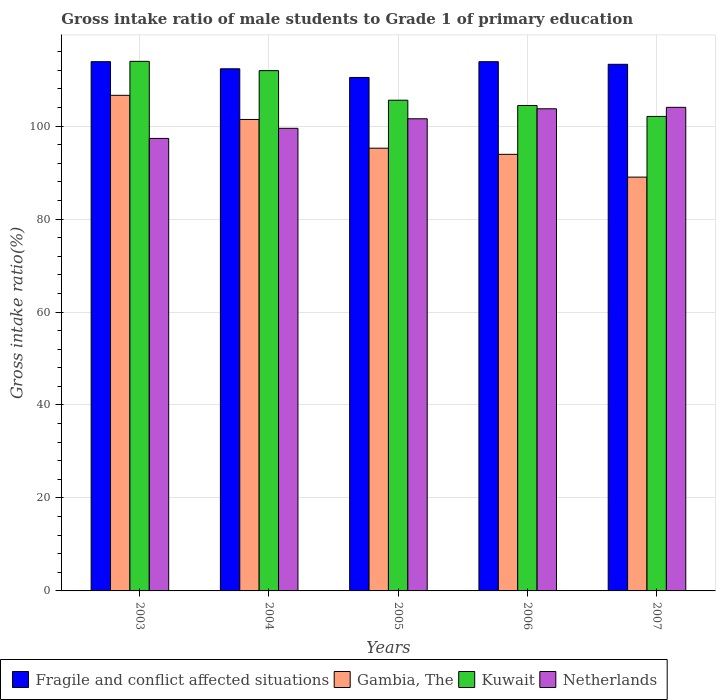How many groups of bars are there?
Ensure brevity in your answer.  5. Are the number of bars per tick equal to the number of legend labels?
Give a very brief answer. Yes. How many bars are there on the 2nd tick from the left?
Your answer should be compact. 4. In how many cases, is the number of bars for a given year not equal to the number of legend labels?
Offer a terse response. 0. What is the gross intake ratio in Netherlands in 2006?
Your answer should be very brief. 103.73. Across all years, what is the maximum gross intake ratio in Kuwait?
Offer a very short reply. 113.93. Across all years, what is the minimum gross intake ratio in Fragile and conflict affected situations?
Ensure brevity in your answer.  110.47. In which year was the gross intake ratio in Kuwait minimum?
Keep it short and to the point. 2007. What is the total gross intake ratio in Kuwait in the graph?
Offer a very short reply. 537.97. What is the difference between the gross intake ratio in Fragile and conflict affected situations in 2005 and that in 2007?
Provide a short and direct response. -2.83. What is the difference between the gross intake ratio in Kuwait in 2007 and the gross intake ratio in Netherlands in 2003?
Give a very brief answer. 4.73. What is the average gross intake ratio in Kuwait per year?
Make the answer very short. 107.59. In the year 2004, what is the difference between the gross intake ratio in Netherlands and gross intake ratio in Gambia, The?
Offer a very short reply. -1.9. In how many years, is the gross intake ratio in Fragile and conflict affected situations greater than 8 %?
Your response must be concise. 5. What is the ratio of the gross intake ratio in Gambia, The in 2003 to that in 2007?
Provide a succinct answer. 1.2. Is the gross intake ratio in Gambia, The in 2005 less than that in 2007?
Give a very brief answer. No. Is the difference between the gross intake ratio in Netherlands in 2003 and 2004 greater than the difference between the gross intake ratio in Gambia, The in 2003 and 2004?
Provide a short and direct response. No. What is the difference between the highest and the second highest gross intake ratio in Kuwait?
Your answer should be compact. 2. What is the difference between the highest and the lowest gross intake ratio in Gambia, The?
Offer a very short reply. 17.6. In how many years, is the gross intake ratio in Fragile and conflict affected situations greater than the average gross intake ratio in Fragile and conflict affected situations taken over all years?
Offer a terse response. 3. Is the sum of the gross intake ratio in Kuwait in 2006 and 2007 greater than the maximum gross intake ratio in Gambia, The across all years?
Your response must be concise. Yes. What does the 2nd bar from the left in 2003 represents?
Offer a terse response. Gambia, The. What does the 2nd bar from the right in 2007 represents?
Give a very brief answer. Kuwait. How many bars are there?
Give a very brief answer. 20. How many years are there in the graph?
Your response must be concise. 5. What is the difference between two consecutive major ticks on the Y-axis?
Your answer should be compact. 20. Does the graph contain any zero values?
Offer a very short reply. No. What is the title of the graph?
Ensure brevity in your answer.  Gross intake ratio of male students to Grade 1 of primary education. Does "Dominica" appear as one of the legend labels in the graph?
Provide a short and direct response. No. What is the label or title of the Y-axis?
Offer a very short reply. Gross intake ratio(%). What is the Gross intake ratio(%) of Fragile and conflict affected situations in 2003?
Your answer should be compact. 113.86. What is the Gross intake ratio(%) in Gambia, The in 2003?
Ensure brevity in your answer.  106.63. What is the Gross intake ratio(%) of Kuwait in 2003?
Your answer should be compact. 113.93. What is the Gross intake ratio(%) of Netherlands in 2003?
Offer a terse response. 97.35. What is the Gross intake ratio(%) of Fragile and conflict affected situations in 2004?
Keep it short and to the point. 112.33. What is the Gross intake ratio(%) of Gambia, The in 2004?
Offer a terse response. 101.43. What is the Gross intake ratio(%) in Kuwait in 2004?
Provide a short and direct response. 111.94. What is the Gross intake ratio(%) of Netherlands in 2004?
Your answer should be very brief. 99.53. What is the Gross intake ratio(%) in Fragile and conflict affected situations in 2005?
Your answer should be very brief. 110.47. What is the Gross intake ratio(%) of Gambia, The in 2005?
Keep it short and to the point. 95.25. What is the Gross intake ratio(%) in Kuwait in 2005?
Your answer should be compact. 105.57. What is the Gross intake ratio(%) in Netherlands in 2005?
Provide a short and direct response. 101.58. What is the Gross intake ratio(%) of Fragile and conflict affected situations in 2006?
Give a very brief answer. 113.86. What is the Gross intake ratio(%) of Gambia, The in 2006?
Provide a succinct answer. 93.93. What is the Gross intake ratio(%) in Kuwait in 2006?
Your answer should be compact. 104.44. What is the Gross intake ratio(%) of Netherlands in 2006?
Keep it short and to the point. 103.73. What is the Gross intake ratio(%) in Fragile and conflict affected situations in 2007?
Make the answer very short. 113.3. What is the Gross intake ratio(%) of Gambia, The in 2007?
Ensure brevity in your answer.  89.03. What is the Gross intake ratio(%) of Kuwait in 2007?
Offer a terse response. 102.08. What is the Gross intake ratio(%) in Netherlands in 2007?
Offer a very short reply. 104.04. Across all years, what is the maximum Gross intake ratio(%) in Fragile and conflict affected situations?
Offer a terse response. 113.86. Across all years, what is the maximum Gross intake ratio(%) of Gambia, The?
Provide a short and direct response. 106.63. Across all years, what is the maximum Gross intake ratio(%) in Kuwait?
Your answer should be compact. 113.93. Across all years, what is the maximum Gross intake ratio(%) in Netherlands?
Ensure brevity in your answer.  104.04. Across all years, what is the minimum Gross intake ratio(%) of Fragile and conflict affected situations?
Ensure brevity in your answer.  110.47. Across all years, what is the minimum Gross intake ratio(%) of Gambia, The?
Offer a very short reply. 89.03. Across all years, what is the minimum Gross intake ratio(%) in Kuwait?
Provide a succinct answer. 102.08. Across all years, what is the minimum Gross intake ratio(%) in Netherlands?
Keep it short and to the point. 97.35. What is the total Gross intake ratio(%) of Fragile and conflict affected situations in the graph?
Ensure brevity in your answer.  563.82. What is the total Gross intake ratio(%) in Gambia, The in the graph?
Provide a succinct answer. 486.26. What is the total Gross intake ratio(%) of Kuwait in the graph?
Provide a succinct answer. 537.97. What is the total Gross intake ratio(%) in Netherlands in the graph?
Your response must be concise. 506.23. What is the difference between the Gross intake ratio(%) in Fragile and conflict affected situations in 2003 and that in 2004?
Provide a short and direct response. 1.53. What is the difference between the Gross intake ratio(%) in Gambia, The in 2003 and that in 2004?
Provide a succinct answer. 5.19. What is the difference between the Gross intake ratio(%) of Kuwait in 2003 and that in 2004?
Ensure brevity in your answer.  2. What is the difference between the Gross intake ratio(%) of Netherlands in 2003 and that in 2004?
Your answer should be very brief. -2.18. What is the difference between the Gross intake ratio(%) in Fragile and conflict affected situations in 2003 and that in 2005?
Provide a succinct answer. 3.39. What is the difference between the Gross intake ratio(%) in Gambia, The in 2003 and that in 2005?
Your answer should be compact. 11.38. What is the difference between the Gross intake ratio(%) of Kuwait in 2003 and that in 2005?
Your response must be concise. 8.36. What is the difference between the Gross intake ratio(%) in Netherlands in 2003 and that in 2005?
Make the answer very short. -4.23. What is the difference between the Gross intake ratio(%) in Fragile and conflict affected situations in 2003 and that in 2006?
Provide a short and direct response. 0. What is the difference between the Gross intake ratio(%) of Gambia, The in 2003 and that in 2006?
Ensure brevity in your answer.  12.7. What is the difference between the Gross intake ratio(%) in Kuwait in 2003 and that in 2006?
Keep it short and to the point. 9.49. What is the difference between the Gross intake ratio(%) of Netherlands in 2003 and that in 2006?
Offer a terse response. -6.38. What is the difference between the Gross intake ratio(%) of Fragile and conflict affected situations in 2003 and that in 2007?
Offer a terse response. 0.56. What is the difference between the Gross intake ratio(%) of Gambia, The in 2003 and that in 2007?
Your response must be concise. 17.6. What is the difference between the Gross intake ratio(%) of Kuwait in 2003 and that in 2007?
Your response must be concise. 11.85. What is the difference between the Gross intake ratio(%) of Netherlands in 2003 and that in 2007?
Offer a very short reply. -6.69. What is the difference between the Gross intake ratio(%) in Fragile and conflict affected situations in 2004 and that in 2005?
Your response must be concise. 1.86. What is the difference between the Gross intake ratio(%) in Gambia, The in 2004 and that in 2005?
Provide a succinct answer. 6.18. What is the difference between the Gross intake ratio(%) in Kuwait in 2004 and that in 2005?
Offer a terse response. 6.36. What is the difference between the Gross intake ratio(%) in Netherlands in 2004 and that in 2005?
Keep it short and to the point. -2.05. What is the difference between the Gross intake ratio(%) in Fragile and conflict affected situations in 2004 and that in 2006?
Provide a succinct answer. -1.53. What is the difference between the Gross intake ratio(%) of Gambia, The in 2004 and that in 2006?
Keep it short and to the point. 7.5. What is the difference between the Gross intake ratio(%) of Kuwait in 2004 and that in 2006?
Your response must be concise. 7.49. What is the difference between the Gross intake ratio(%) of Netherlands in 2004 and that in 2006?
Ensure brevity in your answer.  -4.2. What is the difference between the Gross intake ratio(%) of Fragile and conflict affected situations in 2004 and that in 2007?
Offer a very short reply. -0.97. What is the difference between the Gross intake ratio(%) in Gambia, The in 2004 and that in 2007?
Make the answer very short. 12.4. What is the difference between the Gross intake ratio(%) in Kuwait in 2004 and that in 2007?
Your answer should be compact. 9.85. What is the difference between the Gross intake ratio(%) in Netherlands in 2004 and that in 2007?
Offer a very short reply. -4.51. What is the difference between the Gross intake ratio(%) of Fragile and conflict affected situations in 2005 and that in 2006?
Offer a very short reply. -3.39. What is the difference between the Gross intake ratio(%) of Gambia, The in 2005 and that in 2006?
Provide a short and direct response. 1.32. What is the difference between the Gross intake ratio(%) of Kuwait in 2005 and that in 2006?
Give a very brief answer. 1.13. What is the difference between the Gross intake ratio(%) of Netherlands in 2005 and that in 2006?
Provide a succinct answer. -2.15. What is the difference between the Gross intake ratio(%) of Fragile and conflict affected situations in 2005 and that in 2007?
Offer a terse response. -2.83. What is the difference between the Gross intake ratio(%) in Gambia, The in 2005 and that in 2007?
Your answer should be compact. 6.22. What is the difference between the Gross intake ratio(%) in Kuwait in 2005 and that in 2007?
Offer a very short reply. 3.49. What is the difference between the Gross intake ratio(%) in Netherlands in 2005 and that in 2007?
Make the answer very short. -2.46. What is the difference between the Gross intake ratio(%) in Fragile and conflict affected situations in 2006 and that in 2007?
Provide a short and direct response. 0.56. What is the difference between the Gross intake ratio(%) in Gambia, The in 2006 and that in 2007?
Offer a very short reply. 4.9. What is the difference between the Gross intake ratio(%) of Kuwait in 2006 and that in 2007?
Your answer should be very brief. 2.36. What is the difference between the Gross intake ratio(%) in Netherlands in 2006 and that in 2007?
Your answer should be very brief. -0.31. What is the difference between the Gross intake ratio(%) in Fragile and conflict affected situations in 2003 and the Gross intake ratio(%) in Gambia, The in 2004?
Your answer should be compact. 12.43. What is the difference between the Gross intake ratio(%) of Fragile and conflict affected situations in 2003 and the Gross intake ratio(%) of Kuwait in 2004?
Your response must be concise. 1.93. What is the difference between the Gross intake ratio(%) of Fragile and conflict affected situations in 2003 and the Gross intake ratio(%) of Netherlands in 2004?
Give a very brief answer. 14.34. What is the difference between the Gross intake ratio(%) of Gambia, The in 2003 and the Gross intake ratio(%) of Kuwait in 2004?
Make the answer very short. -5.31. What is the difference between the Gross intake ratio(%) in Gambia, The in 2003 and the Gross intake ratio(%) in Netherlands in 2004?
Your response must be concise. 7.1. What is the difference between the Gross intake ratio(%) in Kuwait in 2003 and the Gross intake ratio(%) in Netherlands in 2004?
Ensure brevity in your answer.  14.41. What is the difference between the Gross intake ratio(%) of Fragile and conflict affected situations in 2003 and the Gross intake ratio(%) of Gambia, The in 2005?
Offer a very short reply. 18.61. What is the difference between the Gross intake ratio(%) of Fragile and conflict affected situations in 2003 and the Gross intake ratio(%) of Kuwait in 2005?
Offer a terse response. 8.29. What is the difference between the Gross intake ratio(%) of Fragile and conflict affected situations in 2003 and the Gross intake ratio(%) of Netherlands in 2005?
Your answer should be compact. 12.28. What is the difference between the Gross intake ratio(%) of Gambia, The in 2003 and the Gross intake ratio(%) of Kuwait in 2005?
Give a very brief answer. 1.05. What is the difference between the Gross intake ratio(%) of Gambia, The in 2003 and the Gross intake ratio(%) of Netherlands in 2005?
Your answer should be compact. 5.04. What is the difference between the Gross intake ratio(%) of Kuwait in 2003 and the Gross intake ratio(%) of Netherlands in 2005?
Provide a short and direct response. 12.35. What is the difference between the Gross intake ratio(%) of Fragile and conflict affected situations in 2003 and the Gross intake ratio(%) of Gambia, The in 2006?
Your response must be concise. 19.93. What is the difference between the Gross intake ratio(%) in Fragile and conflict affected situations in 2003 and the Gross intake ratio(%) in Kuwait in 2006?
Give a very brief answer. 9.42. What is the difference between the Gross intake ratio(%) in Fragile and conflict affected situations in 2003 and the Gross intake ratio(%) in Netherlands in 2006?
Offer a terse response. 10.13. What is the difference between the Gross intake ratio(%) of Gambia, The in 2003 and the Gross intake ratio(%) of Kuwait in 2006?
Your answer should be very brief. 2.18. What is the difference between the Gross intake ratio(%) of Gambia, The in 2003 and the Gross intake ratio(%) of Netherlands in 2006?
Ensure brevity in your answer.  2.89. What is the difference between the Gross intake ratio(%) of Kuwait in 2003 and the Gross intake ratio(%) of Netherlands in 2006?
Provide a succinct answer. 10.2. What is the difference between the Gross intake ratio(%) of Fragile and conflict affected situations in 2003 and the Gross intake ratio(%) of Gambia, The in 2007?
Provide a succinct answer. 24.83. What is the difference between the Gross intake ratio(%) in Fragile and conflict affected situations in 2003 and the Gross intake ratio(%) in Kuwait in 2007?
Your answer should be compact. 11.78. What is the difference between the Gross intake ratio(%) in Fragile and conflict affected situations in 2003 and the Gross intake ratio(%) in Netherlands in 2007?
Offer a very short reply. 9.82. What is the difference between the Gross intake ratio(%) in Gambia, The in 2003 and the Gross intake ratio(%) in Kuwait in 2007?
Keep it short and to the point. 4.54. What is the difference between the Gross intake ratio(%) of Gambia, The in 2003 and the Gross intake ratio(%) of Netherlands in 2007?
Make the answer very short. 2.58. What is the difference between the Gross intake ratio(%) of Kuwait in 2003 and the Gross intake ratio(%) of Netherlands in 2007?
Provide a short and direct response. 9.89. What is the difference between the Gross intake ratio(%) of Fragile and conflict affected situations in 2004 and the Gross intake ratio(%) of Gambia, The in 2005?
Your answer should be very brief. 17.08. What is the difference between the Gross intake ratio(%) of Fragile and conflict affected situations in 2004 and the Gross intake ratio(%) of Kuwait in 2005?
Provide a short and direct response. 6.76. What is the difference between the Gross intake ratio(%) in Fragile and conflict affected situations in 2004 and the Gross intake ratio(%) in Netherlands in 2005?
Offer a very short reply. 10.75. What is the difference between the Gross intake ratio(%) of Gambia, The in 2004 and the Gross intake ratio(%) of Kuwait in 2005?
Your response must be concise. -4.14. What is the difference between the Gross intake ratio(%) of Gambia, The in 2004 and the Gross intake ratio(%) of Netherlands in 2005?
Offer a terse response. -0.15. What is the difference between the Gross intake ratio(%) in Kuwait in 2004 and the Gross intake ratio(%) in Netherlands in 2005?
Provide a short and direct response. 10.36. What is the difference between the Gross intake ratio(%) of Fragile and conflict affected situations in 2004 and the Gross intake ratio(%) of Gambia, The in 2006?
Your response must be concise. 18.4. What is the difference between the Gross intake ratio(%) of Fragile and conflict affected situations in 2004 and the Gross intake ratio(%) of Kuwait in 2006?
Ensure brevity in your answer.  7.89. What is the difference between the Gross intake ratio(%) of Fragile and conflict affected situations in 2004 and the Gross intake ratio(%) of Netherlands in 2006?
Your response must be concise. 8.6. What is the difference between the Gross intake ratio(%) in Gambia, The in 2004 and the Gross intake ratio(%) in Kuwait in 2006?
Your response must be concise. -3.01. What is the difference between the Gross intake ratio(%) of Gambia, The in 2004 and the Gross intake ratio(%) of Netherlands in 2006?
Your answer should be compact. -2.3. What is the difference between the Gross intake ratio(%) of Kuwait in 2004 and the Gross intake ratio(%) of Netherlands in 2006?
Your answer should be compact. 8.21. What is the difference between the Gross intake ratio(%) of Fragile and conflict affected situations in 2004 and the Gross intake ratio(%) of Gambia, The in 2007?
Provide a succinct answer. 23.3. What is the difference between the Gross intake ratio(%) in Fragile and conflict affected situations in 2004 and the Gross intake ratio(%) in Kuwait in 2007?
Provide a succinct answer. 10.25. What is the difference between the Gross intake ratio(%) in Fragile and conflict affected situations in 2004 and the Gross intake ratio(%) in Netherlands in 2007?
Offer a very short reply. 8.29. What is the difference between the Gross intake ratio(%) of Gambia, The in 2004 and the Gross intake ratio(%) of Kuwait in 2007?
Your response must be concise. -0.65. What is the difference between the Gross intake ratio(%) of Gambia, The in 2004 and the Gross intake ratio(%) of Netherlands in 2007?
Keep it short and to the point. -2.61. What is the difference between the Gross intake ratio(%) in Kuwait in 2004 and the Gross intake ratio(%) in Netherlands in 2007?
Your answer should be very brief. 7.9. What is the difference between the Gross intake ratio(%) in Fragile and conflict affected situations in 2005 and the Gross intake ratio(%) in Gambia, The in 2006?
Offer a very short reply. 16.54. What is the difference between the Gross intake ratio(%) in Fragile and conflict affected situations in 2005 and the Gross intake ratio(%) in Kuwait in 2006?
Provide a short and direct response. 6.03. What is the difference between the Gross intake ratio(%) of Fragile and conflict affected situations in 2005 and the Gross intake ratio(%) of Netherlands in 2006?
Keep it short and to the point. 6.74. What is the difference between the Gross intake ratio(%) in Gambia, The in 2005 and the Gross intake ratio(%) in Kuwait in 2006?
Offer a terse response. -9.19. What is the difference between the Gross intake ratio(%) in Gambia, The in 2005 and the Gross intake ratio(%) in Netherlands in 2006?
Ensure brevity in your answer.  -8.48. What is the difference between the Gross intake ratio(%) of Kuwait in 2005 and the Gross intake ratio(%) of Netherlands in 2006?
Provide a short and direct response. 1.84. What is the difference between the Gross intake ratio(%) in Fragile and conflict affected situations in 2005 and the Gross intake ratio(%) in Gambia, The in 2007?
Make the answer very short. 21.44. What is the difference between the Gross intake ratio(%) in Fragile and conflict affected situations in 2005 and the Gross intake ratio(%) in Kuwait in 2007?
Keep it short and to the point. 8.38. What is the difference between the Gross intake ratio(%) in Fragile and conflict affected situations in 2005 and the Gross intake ratio(%) in Netherlands in 2007?
Offer a terse response. 6.43. What is the difference between the Gross intake ratio(%) of Gambia, The in 2005 and the Gross intake ratio(%) of Kuwait in 2007?
Ensure brevity in your answer.  -6.84. What is the difference between the Gross intake ratio(%) in Gambia, The in 2005 and the Gross intake ratio(%) in Netherlands in 2007?
Ensure brevity in your answer.  -8.79. What is the difference between the Gross intake ratio(%) of Kuwait in 2005 and the Gross intake ratio(%) of Netherlands in 2007?
Offer a terse response. 1.53. What is the difference between the Gross intake ratio(%) of Fragile and conflict affected situations in 2006 and the Gross intake ratio(%) of Gambia, The in 2007?
Offer a very short reply. 24.83. What is the difference between the Gross intake ratio(%) in Fragile and conflict affected situations in 2006 and the Gross intake ratio(%) in Kuwait in 2007?
Your answer should be very brief. 11.78. What is the difference between the Gross intake ratio(%) in Fragile and conflict affected situations in 2006 and the Gross intake ratio(%) in Netherlands in 2007?
Provide a succinct answer. 9.82. What is the difference between the Gross intake ratio(%) in Gambia, The in 2006 and the Gross intake ratio(%) in Kuwait in 2007?
Your response must be concise. -8.16. What is the difference between the Gross intake ratio(%) of Gambia, The in 2006 and the Gross intake ratio(%) of Netherlands in 2007?
Offer a very short reply. -10.11. What is the difference between the Gross intake ratio(%) in Kuwait in 2006 and the Gross intake ratio(%) in Netherlands in 2007?
Make the answer very short. 0.4. What is the average Gross intake ratio(%) in Fragile and conflict affected situations per year?
Give a very brief answer. 112.76. What is the average Gross intake ratio(%) of Gambia, The per year?
Provide a short and direct response. 97.25. What is the average Gross intake ratio(%) of Kuwait per year?
Offer a very short reply. 107.59. What is the average Gross intake ratio(%) of Netherlands per year?
Provide a short and direct response. 101.25. In the year 2003, what is the difference between the Gross intake ratio(%) of Fragile and conflict affected situations and Gross intake ratio(%) of Gambia, The?
Provide a short and direct response. 7.24. In the year 2003, what is the difference between the Gross intake ratio(%) in Fragile and conflict affected situations and Gross intake ratio(%) in Kuwait?
Your response must be concise. -0.07. In the year 2003, what is the difference between the Gross intake ratio(%) of Fragile and conflict affected situations and Gross intake ratio(%) of Netherlands?
Keep it short and to the point. 16.51. In the year 2003, what is the difference between the Gross intake ratio(%) in Gambia, The and Gross intake ratio(%) in Kuwait?
Provide a succinct answer. -7.31. In the year 2003, what is the difference between the Gross intake ratio(%) of Gambia, The and Gross intake ratio(%) of Netherlands?
Give a very brief answer. 9.28. In the year 2003, what is the difference between the Gross intake ratio(%) in Kuwait and Gross intake ratio(%) in Netherlands?
Your response must be concise. 16.58. In the year 2004, what is the difference between the Gross intake ratio(%) in Fragile and conflict affected situations and Gross intake ratio(%) in Gambia, The?
Your response must be concise. 10.9. In the year 2004, what is the difference between the Gross intake ratio(%) of Fragile and conflict affected situations and Gross intake ratio(%) of Kuwait?
Provide a succinct answer. 0.4. In the year 2004, what is the difference between the Gross intake ratio(%) of Fragile and conflict affected situations and Gross intake ratio(%) of Netherlands?
Your answer should be very brief. 12.81. In the year 2004, what is the difference between the Gross intake ratio(%) of Gambia, The and Gross intake ratio(%) of Kuwait?
Keep it short and to the point. -10.51. In the year 2004, what is the difference between the Gross intake ratio(%) of Gambia, The and Gross intake ratio(%) of Netherlands?
Provide a short and direct response. 1.9. In the year 2004, what is the difference between the Gross intake ratio(%) of Kuwait and Gross intake ratio(%) of Netherlands?
Provide a short and direct response. 12.41. In the year 2005, what is the difference between the Gross intake ratio(%) of Fragile and conflict affected situations and Gross intake ratio(%) of Gambia, The?
Give a very brief answer. 15.22. In the year 2005, what is the difference between the Gross intake ratio(%) in Fragile and conflict affected situations and Gross intake ratio(%) in Kuwait?
Offer a very short reply. 4.89. In the year 2005, what is the difference between the Gross intake ratio(%) of Fragile and conflict affected situations and Gross intake ratio(%) of Netherlands?
Provide a succinct answer. 8.89. In the year 2005, what is the difference between the Gross intake ratio(%) in Gambia, The and Gross intake ratio(%) in Kuwait?
Your answer should be very brief. -10.32. In the year 2005, what is the difference between the Gross intake ratio(%) in Gambia, The and Gross intake ratio(%) in Netherlands?
Provide a short and direct response. -6.33. In the year 2005, what is the difference between the Gross intake ratio(%) in Kuwait and Gross intake ratio(%) in Netherlands?
Give a very brief answer. 3.99. In the year 2006, what is the difference between the Gross intake ratio(%) of Fragile and conflict affected situations and Gross intake ratio(%) of Gambia, The?
Your answer should be compact. 19.93. In the year 2006, what is the difference between the Gross intake ratio(%) of Fragile and conflict affected situations and Gross intake ratio(%) of Kuwait?
Your answer should be very brief. 9.42. In the year 2006, what is the difference between the Gross intake ratio(%) of Fragile and conflict affected situations and Gross intake ratio(%) of Netherlands?
Your answer should be very brief. 10.13. In the year 2006, what is the difference between the Gross intake ratio(%) of Gambia, The and Gross intake ratio(%) of Kuwait?
Give a very brief answer. -10.51. In the year 2006, what is the difference between the Gross intake ratio(%) in Gambia, The and Gross intake ratio(%) in Netherlands?
Keep it short and to the point. -9.8. In the year 2006, what is the difference between the Gross intake ratio(%) in Kuwait and Gross intake ratio(%) in Netherlands?
Give a very brief answer. 0.71. In the year 2007, what is the difference between the Gross intake ratio(%) in Fragile and conflict affected situations and Gross intake ratio(%) in Gambia, The?
Offer a very short reply. 24.27. In the year 2007, what is the difference between the Gross intake ratio(%) of Fragile and conflict affected situations and Gross intake ratio(%) of Kuwait?
Your answer should be compact. 11.21. In the year 2007, what is the difference between the Gross intake ratio(%) of Fragile and conflict affected situations and Gross intake ratio(%) of Netherlands?
Offer a very short reply. 9.26. In the year 2007, what is the difference between the Gross intake ratio(%) in Gambia, The and Gross intake ratio(%) in Kuwait?
Make the answer very short. -13.06. In the year 2007, what is the difference between the Gross intake ratio(%) in Gambia, The and Gross intake ratio(%) in Netherlands?
Your answer should be compact. -15.01. In the year 2007, what is the difference between the Gross intake ratio(%) of Kuwait and Gross intake ratio(%) of Netherlands?
Ensure brevity in your answer.  -1.96. What is the ratio of the Gross intake ratio(%) of Fragile and conflict affected situations in 2003 to that in 2004?
Keep it short and to the point. 1.01. What is the ratio of the Gross intake ratio(%) in Gambia, The in 2003 to that in 2004?
Offer a terse response. 1.05. What is the ratio of the Gross intake ratio(%) in Kuwait in 2003 to that in 2004?
Ensure brevity in your answer.  1.02. What is the ratio of the Gross intake ratio(%) of Netherlands in 2003 to that in 2004?
Ensure brevity in your answer.  0.98. What is the ratio of the Gross intake ratio(%) in Fragile and conflict affected situations in 2003 to that in 2005?
Your answer should be compact. 1.03. What is the ratio of the Gross intake ratio(%) in Gambia, The in 2003 to that in 2005?
Your response must be concise. 1.12. What is the ratio of the Gross intake ratio(%) in Kuwait in 2003 to that in 2005?
Offer a terse response. 1.08. What is the ratio of the Gross intake ratio(%) of Netherlands in 2003 to that in 2005?
Ensure brevity in your answer.  0.96. What is the ratio of the Gross intake ratio(%) of Gambia, The in 2003 to that in 2006?
Your response must be concise. 1.14. What is the ratio of the Gross intake ratio(%) in Netherlands in 2003 to that in 2006?
Make the answer very short. 0.94. What is the ratio of the Gross intake ratio(%) of Fragile and conflict affected situations in 2003 to that in 2007?
Provide a short and direct response. 1. What is the ratio of the Gross intake ratio(%) of Gambia, The in 2003 to that in 2007?
Your answer should be very brief. 1.2. What is the ratio of the Gross intake ratio(%) of Kuwait in 2003 to that in 2007?
Offer a very short reply. 1.12. What is the ratio of the Gross intake ratio(%) of Netherlands in 2003 to that in 2007?
Offer a terse response. 0.94. What is the ratio of the Gross intake ratio(%) of Fragile and conflict affected situations in 2004 to that in 2005?
Offer a terse response. 1.02. What is the ratio of the Gross intake ratio(%) of Gambia, The in 2004 to that in 2005?
Your answer should be compact. 1.06. What is the ratio of the Gross intake ratio(%) in Kuwait in 2004 to that in 2005?
Keep it short and to the point. 1.06. What is the ratio of the Gross intake ratio(%) of Netherlands in 2004 to that in 2005?
Your response must be concise. 0.98. What is the ratio of the Gross intake ratio(%) of Fragile and conflict affected situations in 2004 to that in 2006?
Ensure brevity in your answer.  0.99. What is the ratio of the Gross intake ratio(%) in Gambia, The in 2004 to that in 2006?
Your response must be concise. 1.08. What is the ratio of the Gross intake ratio(%) in Kuwait in 2004 to that in 2006?
Your answer should be compact. 1.07. What is the ratio of the Gross intake ratio(%) of Netherlands in 2004 to that in 2006?
Ensure brevity in your answer.  0.96. What is the ratio of the Gross intake ratio(%) of Gambia, The in 2004 to that in 2007?
Offer a very short reply. 1.14. What is the ratio of the Gross intake ratio(%) of Kuwait in 2004 to that in 2007?
Provide a short and direct response. 1.1. What is the ratio of the Gross intake ratio(%) of Netherlands in 2004 to that in 2007?
Keep it short and to the point. 0.96. What is the ratio of the Gross intake ratio(%) in Fragile and conflict affected situations in 2005 to that in 2006?
Your answer should be compact. 0.97. What is the ratio of the Gross intake ratio(%) of Gambia, The in 2005 to that in 2006?
Provide a succinct answer. 1.01. What is the ratio of the Gross intake ratio(%) in Kuwait in 2005 to that in 2006?
Offer a terse response. 1.01. What is the ratio of the Gross intake ratio(%) in Netherlands in 2005 to that in 2006?
Your response must be concise. 0.98. What is the ratio of the Gross intake ratio(%) in Gambia, The in 2005 to that in 2007?
Give a very brief answer. 1.07. What is the ratio of the Gross intake ratio(%) of Kuwait in 2005 to that in 2007?
Keep it short and to the point. 1.03. What is the ratio of the Gross intake ratio(%) of Netherlands in 2005 to that in 2007?
Offer a terse response. 0.98. What is the ratio of the Gross intake ratio(%) of Gambia, The in 2006 to that in 2007?
Keep it short and to the point. 1.05. What is the ratio of the Gross intake ratio(%) of Kuwait in 2006 to that in 2007?
Your answer should be compact. 1.02. What is the difference between the highest and the second highest Gross intake ratio(%) of Fragile and conflict affected situations?
Offer a very short reply. 0. What is the difference between the highest and the second highest Gross intake ratio(%) of Gambia, The?
Make the answer very short. 5.19. What is the difference between the highest and the second highest Gross intake ratio(%) of Kuwait?
Offer a terse response. 2. What is the difference between the highest and the second highest Gross intake ratio(%) of Netherlands?
Offer a very short reply. 0.31. What is the difference between the highest and the lowest Gross intake ratio(%) of Fragile and conflict affected situations?
Provide a short and direct response. 3.39. What is the difference between the highest and the lowest Gross intake ratio(%) in Gambia, The?
Offer a terse response. 17.6. What is the difference between the highest and the lowest Gross intake ratio(%) in Kuwait?
Ensure brevity in your answer.  11.85. What is the difference between the highest and the lowest Gross intake ratio(%) in Netherlands?
Your response must be concise. 6.69. 